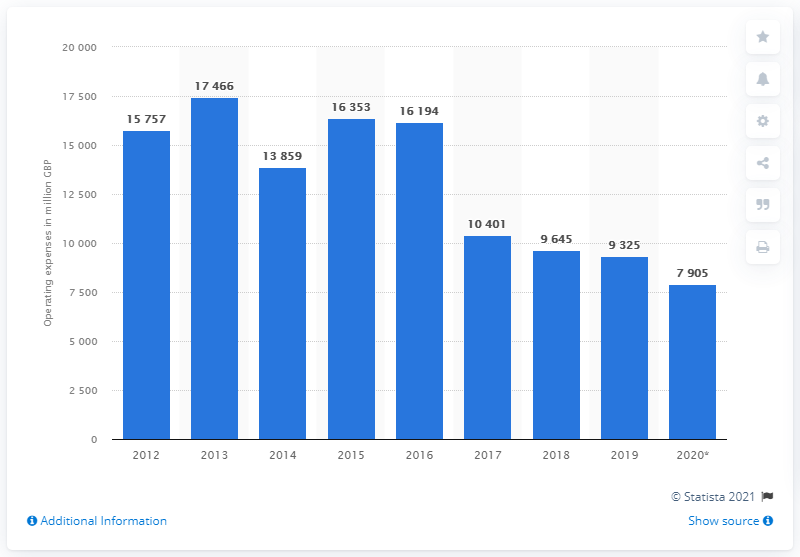Draw attention to some important aspects in this diagram. In 2013, the highest value of the NatWest group's operating costs was 17,466. 